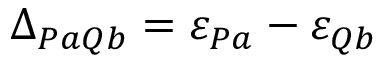Convert formula to latex. <formula><loc_0><loc_0><loc_500><loc_500>\Delta _ { P a Q b } = \varepsilon _ { P a } - \varepsilon _ { Q b }</formula> 